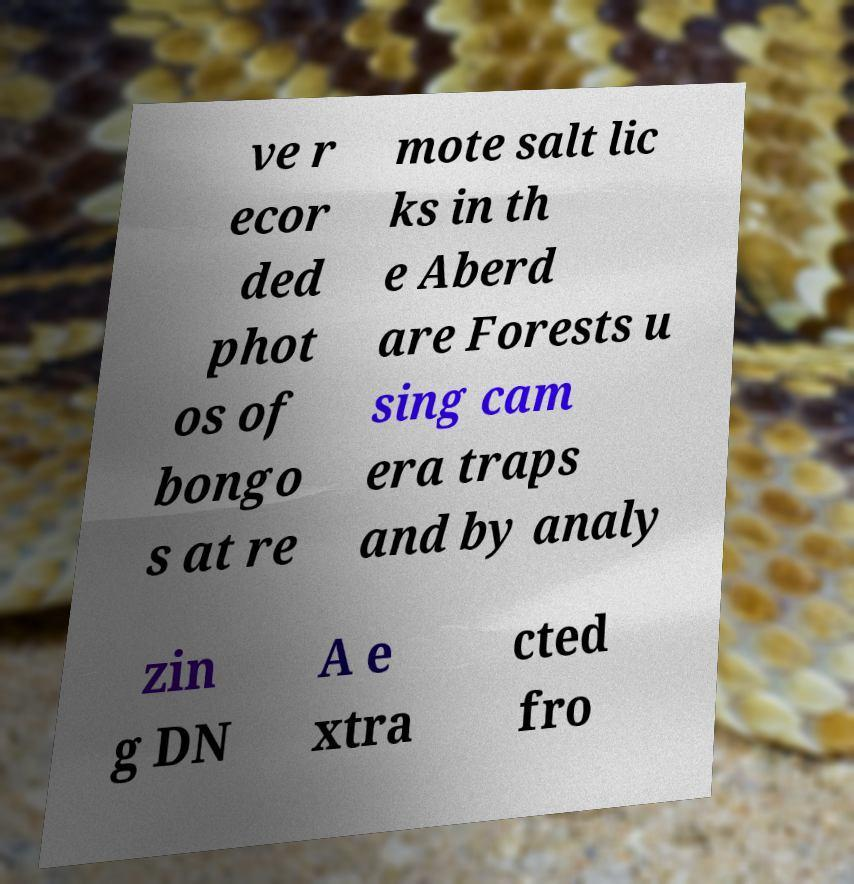For documentation purposes, I need the text within this image transcribed. Could you provide that? ve r ecor ded phot os of bongo s at re mote salt lic ks in th e Aberd are Forests u sing cam era traps and by analy zin g DN A e xtra cted fro 